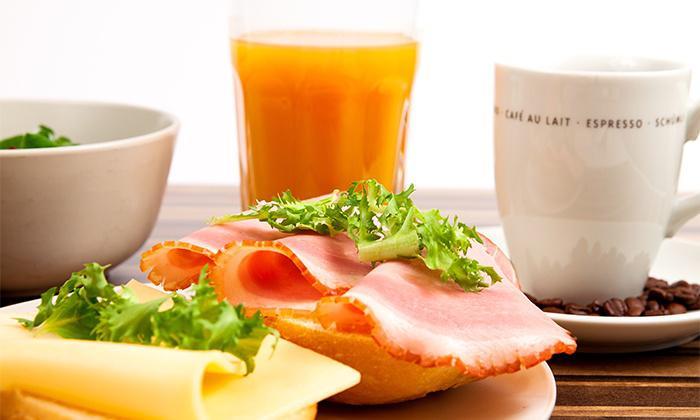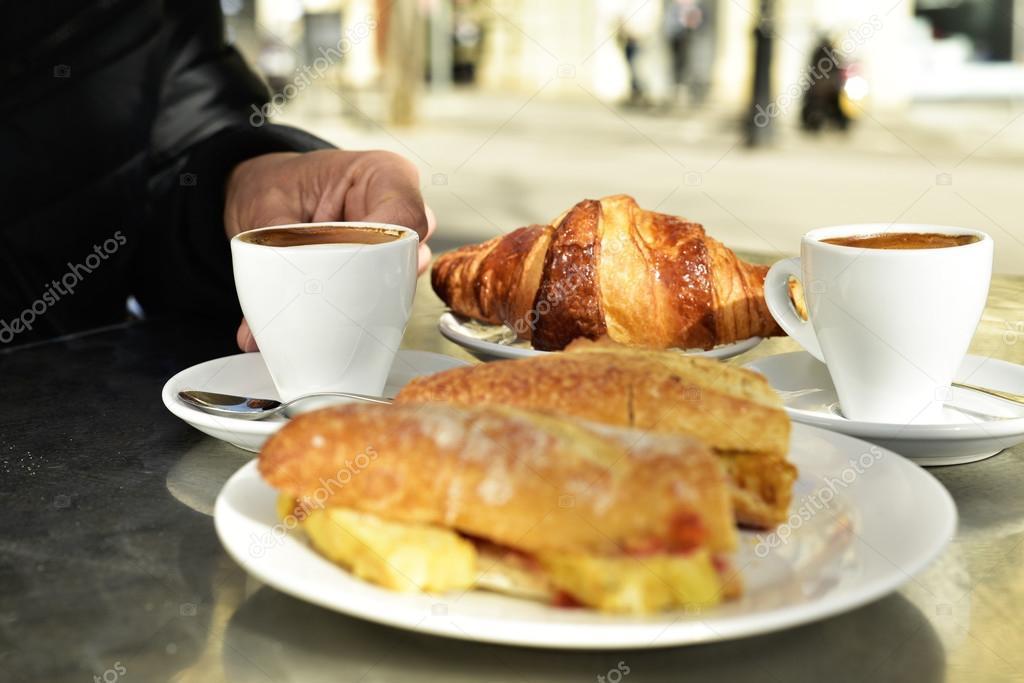The first image is the image on the left, the second image is the image on the right. Examine the images to the left and right. Is the description "The left and right image contains the same number of cups with at least two pastries." accurate? Answer yes or no. Yes. 